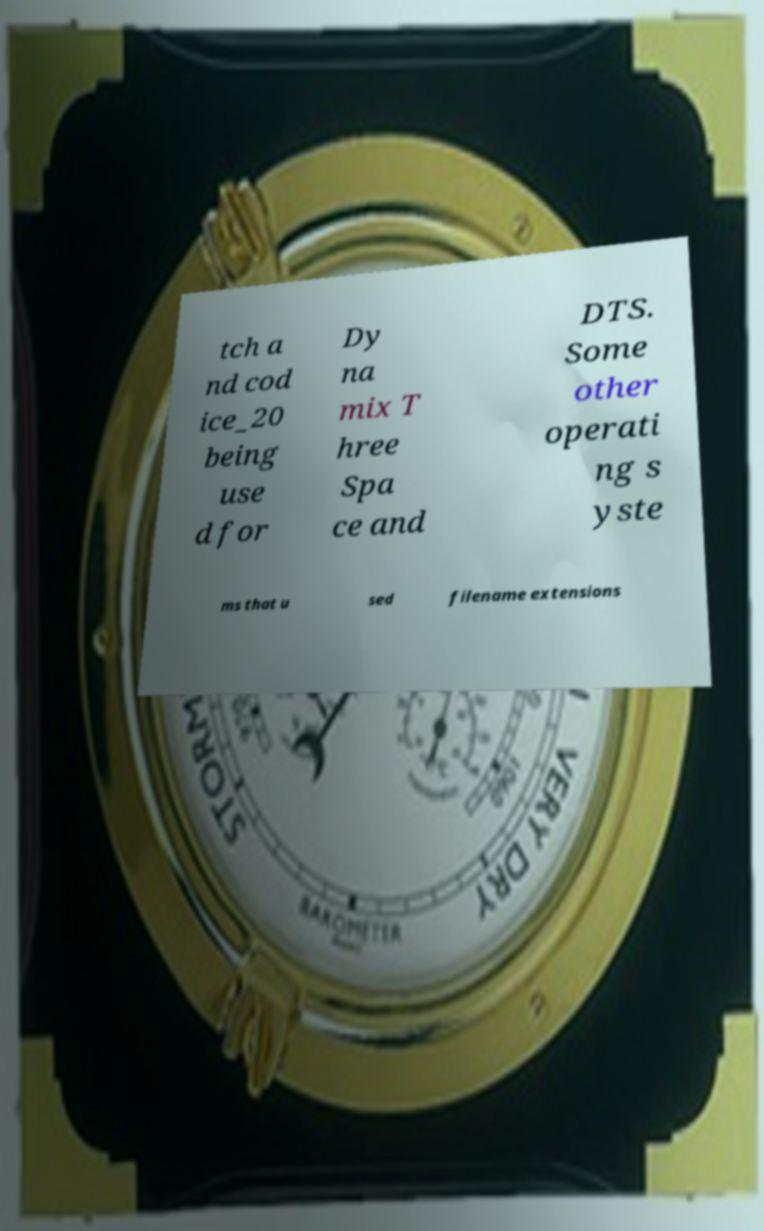Can you read and provide the text displayed in the image?This photo seems to have some interesting text. Can you extract and type it out for me? tch a nd cod ice_20 being use d for Dy na mix T hree Spa ce and DTS. Some other operati ng s yste ms that u sed filename extensions 